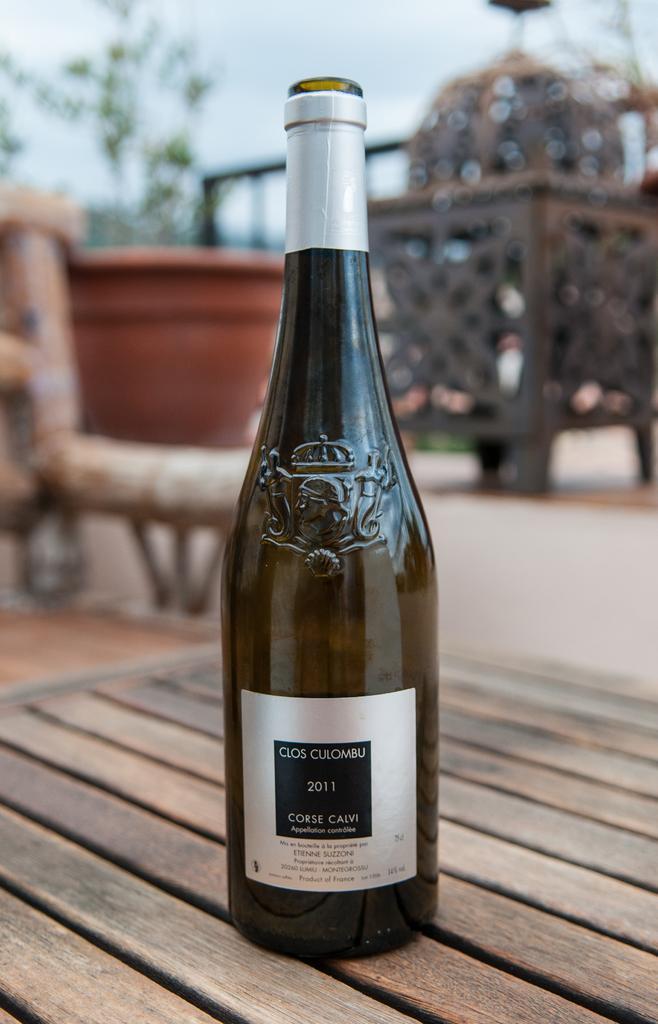Could you give a brief overview of what you see in this image? In this image I can see a bottle on the table. At the back side I can see a flower pot. 